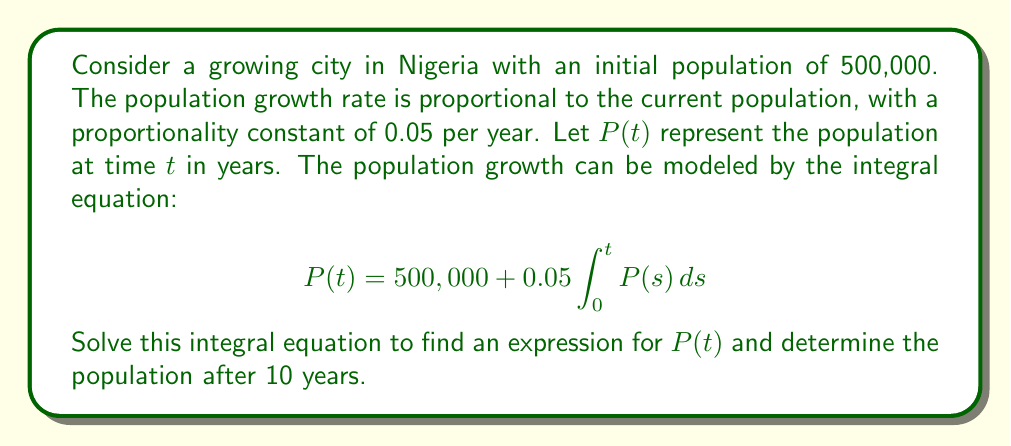Could you help me with this problem? Let's solve this integral equation step by step:

1) First, we recognize this as a Volterra integral equation of the second kind.

2) To solve it, we can differentiate both sides with respect to $t$:

   $$\frac{d}{dt}P(t) = \frac{d}{dt}(500,000) + 0.05 \frac{d}{dt}\int_0^t P(s) ds$$

3) Using the Fundamental Theorem of Calculus:

   $$\frac{dP}{dt} = 0 + 0.05P(t)$$

4) This gives us a differential equation:

   $$\frac{dP}{dt} = 0.05P$$

5) This is a separable differential equation. We can solve it as follows:

   $$\int \frac{dP}{P} = \int 0.05 dt$$

6) Integrating both sides:

   $$\ln|P| = 0.05t + C$$

7) Taking the exponential of both sides:

   $$P = e^{0.05t + C} = Ae^{0.05t}$$

   where $A = e^C$ is a constant.

8) To find $A$, we use the initial condition $P(0) = 500,000$:

   $$500,000 = Ae^{0.05(0)} = A$$

9) Therefore, our solution is:

   $$P(t) = 500,000e^{0.05t}$$

10) To find the population after 10 years, we substitute $t = 10$:

    $$P(10) = 500,000e^{0.05(10)} = 500,000e^{0.5} \approx 824,360$$
Answer: $P(t) = 500,000e^{0.05t}$; Population after 10 years ≈ 824,360 